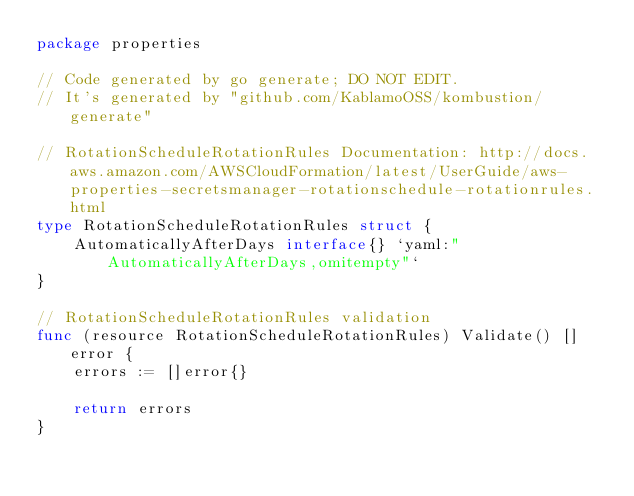Convert code to text. <code><loc_0><loc_0><loc_500><loc_500><_Go_>package properties

// Code generated by go generate; DO NOT EDIT.
// It's generated by "github.com/KablamoOSS/kombustion/generate"

// RotationScheduleRotationRules Documentation: http://docs.aws.amazon.com/AWSCloudFormation/latest/UserGuide/aws-properties-secretsmanager-rotationschedule-rotationrules.html
type RotationScheduleRotationRules struct {
	AutomaticallyAfterDays interface{} `yaml:"AutomaticallyAfterDays,omitempty"`
}

// RotationScheduleRotationRules validation
func (resource RotationScheduleRotationRules) Validate() []error {
	errors := []error{}

	return errors
}
</code> 